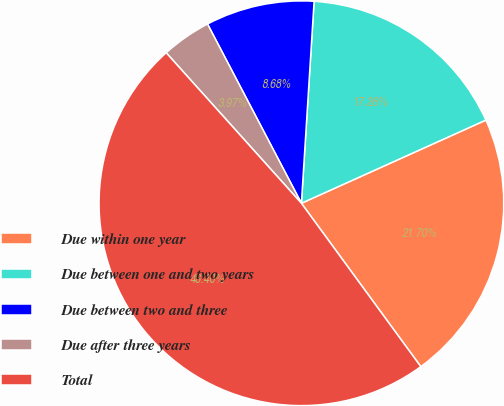<chart> <loc_0><loc_0><loc_500><loc_500><pie_chart><fcel>Due within one year<fcel>Due between one and two years<fcel>Due between two and three<fcel>Due after three years<fcel>Total<nl><fcel>21.7%<fcel>17.26%<fcel>8.68%<fcel>3.97%<fcel>48.4%<nl></chart> 